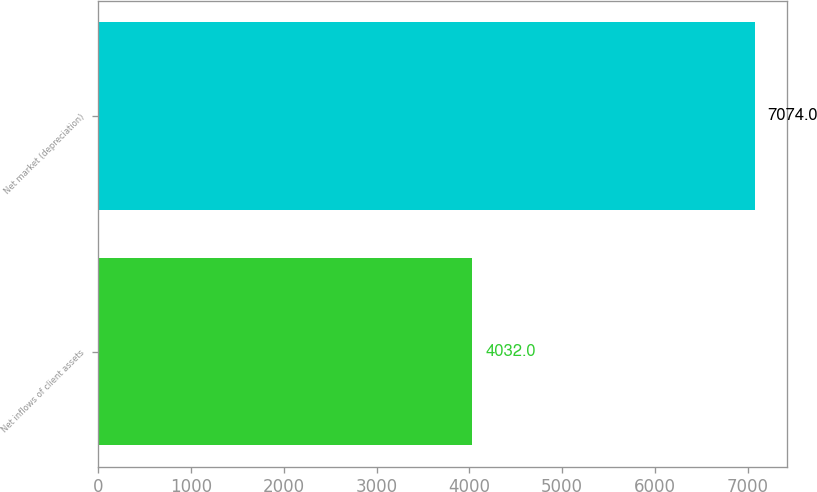Convert chart to OTSL. <chart><loc_0><loc_0><loc_500><loc_500><bar_chart><fcel>Net inflows of client assets<fcel>Net market (depreciation)<nl><fcel>4032<fcel>7074<nl></chart> 